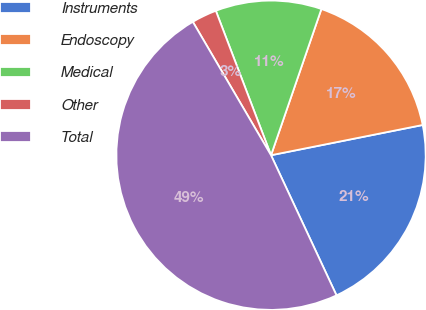<chart> <loc_0><loc_0><loc_500><loc_500><pie_chart><fcel>Instruments<fcel>Endoscopy<fcel>Medical<fcel>Other<fcel>Total<nl><fcel>21.18%<fcel>16.59%<fcel>11.09%<fcel>2.63%<fcel>48.53%<nl></chart> 